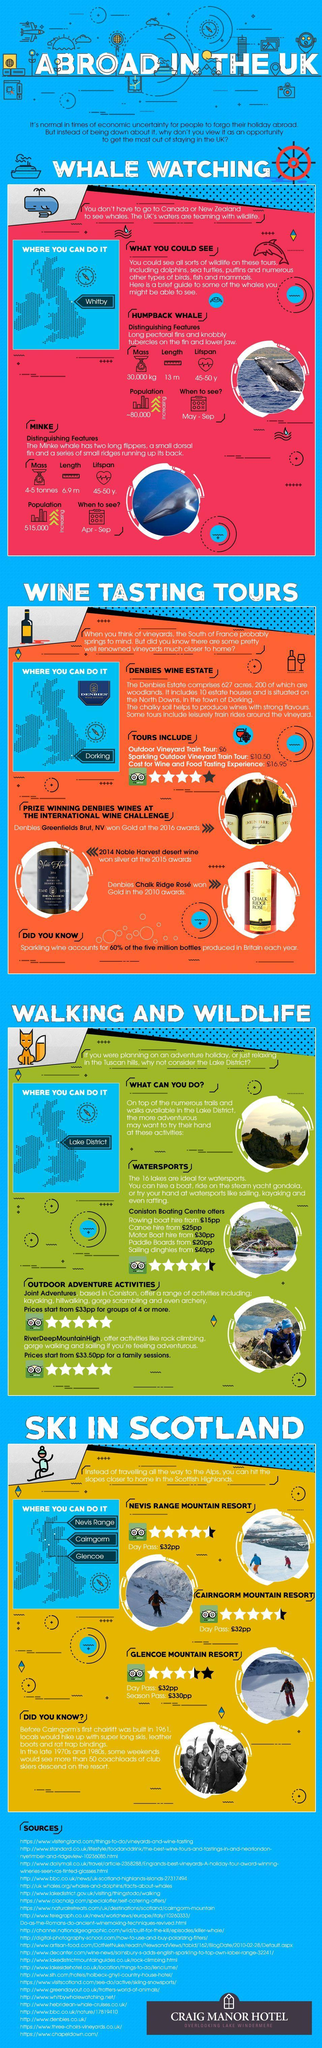Which are the regions which are good for sking in Scotland
Answer the question with a short phrase. Nevis Range, Cairngorm, Glencoe Which ski resorts have the same scores in trip advisor Nevis Range Mountain Resort, Cairngorm Mountain Resort Where can you do whale watching Whitby What is the rating in trip advisor for Glencoe Mountain Resort 3.5 Where can you go for the wine tasting tours Dorking, Denbies Wine Estate Which whale has a mass of 30,000 kg Humpback What is the best time to see a Minke Apr - Sep What is the best time to see a Humpback Whale May - Sep 